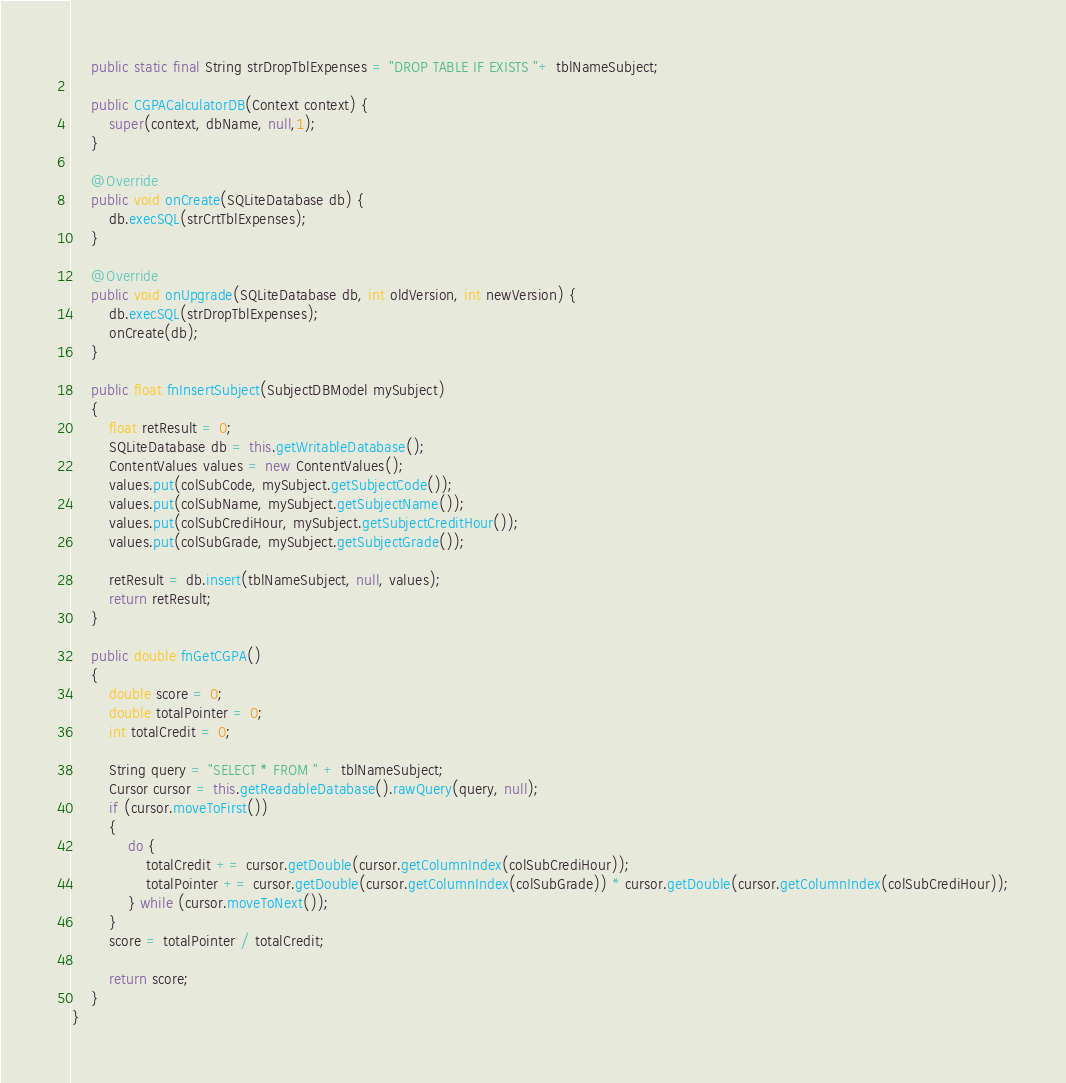<code> <loc_0><loc_0><loc_500><loc_500><_Java_>    public static final String strDropTblExpenses = "DROP TABLE IF EXISTS "+ tblNameSubject;

    public CGPACalculatorDB(Context context) {
        super(context, dbName, null,1);
    }

    @Override
    public void onCreate(SQLiteDatabase db) {
        db.execSQL(strCrtTblExpenses);
    }

    @Override
    public void onUpgrade(SQLiteDatabase db, int oldVersion, int newVersion) {
        db.execSQL(strDropTblExpenses);
        onCreate(db);
    }

    public float fnInsertSubject(SubjectDBModel mySubject)
    {
        float retResult = 0;
        SQLiteDatabase db = this.getWritableDatabase();
        ContentValues values = new ContentValues();
        values.put(colSubCode, mySubject.getSubjectCode());
        values.put(colSubName, mySubject.getSubjectName());
        values.put(colSubCrediHour, mySubject.getSubjectCreditHour());
        values.put(colSubGrade, mySubject.getSubjectGrade());

        retResult = db.insert(tblNameSubject, null, values);
        return retResult;
    }

    public double fnGetCGPA()
    {
        double score = 0;
        double totalPointer = 0;
        int totalCredit = 0;

        String query = "SELECT * FROM " + tblNameSubject;
        Cursor cursor = this.getReadableDatabase().rawQuery(query, null);
        if (cursor.moveToFirst())
        {
            do {
                totalCredit += cursor.getDouble(cursor.getColumnIndex(colSubCrediHour));
                totalPointer += cursor.getDouble(cursor.getColumnIndex(colSubGrade)) * cursor.getDouble(cursor.getColumnIndex(colSubCrediHour));
            } while (cursor.moveToNext());
        }
        score = totalPointer / totalCredit;

        return score;
    }
}
</code> 